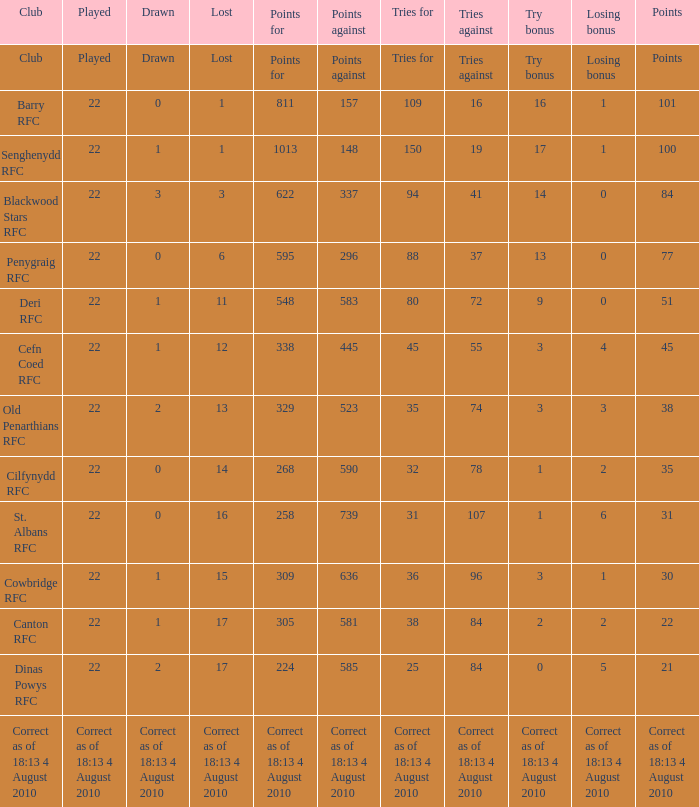What is the played number when tries against is 84, and drawn is 2? 22.0. Parse the full table. {'header': ['Club', 'Played', 'Drawn', 'Lost', 'Points for', 'Points against', 'Tries for', 'Tries against', 'Try bonus', 'Losing bonus', 'Points'], 'rows': [['Club', 'Played', 'Drawn', 'Lost', 'Points for', 'Points against', 'Tries for', 'Tries against', 'Try bonus', 'Losing bonus', 'Points'], ['Barry RFC', '22', '0', '1', '811', '157', '109', '16', '16', '1', '101'], ['Senghenydd RFC', '22', '1', '1', '1013', '148', '150', '19', '17', '1', '100'], ['Blackwood Stars RFC', '22', '3', '3', '622', '337', '94', '41', '14', '0', '84'], ['Penygraig RFC', '22', '0', '6', '595', '296', '88', '37', '13', '0', '77'], ['Deri RFC', '22', '1', '11', '548', '583', '80', '72', '9', '0', '51'], ['Cefn Coed RFC', '22', '1', '12', '338', '445', '45', '55', '3', '4', '45'], ['Old Penarthians RFC', '22', '2', '13', '329', '523', '35', '74', '3', '3', '38'], ['Cilfynydd RFC', '22', '0', '14', '268', '590', '32', '78', '1', '2', '35'], ['St. Albans RFC', '22', '0', '16', '258', '739', '31', '107', '1', '6', '31'], ['Cowbridge RFC', '22', '1', '15', '309', '636', '36', '96', '3', '1', '30'], ['Canton RFC', '22', '1', '17', '305', '581', '38', '84', '2', '2', '22'], ['Dinas Powys RFC', '22', '2', '17', '224', '585', '25', '84', '0', '5', '21'], ['Correct as of 18:13 4 August 2010', 'Correct as of 18:13 4 August 2010', 'Correct as of 18:13 4 August 2010', 'Correct as of 18:13 4 August 2010', 'Correct as of 18:13 4 August 2010', 'Correct as of 18:13 4 August 2010', 'Correct as of 18:13 4 August 2010', 'Correct as of 18:13 4 August 2010', 'Correct as of 18:13 4 August 2010', 'Correct as of 18:13 4 August 2010', 'Correct as of 18:13 4 August 2010']]} 